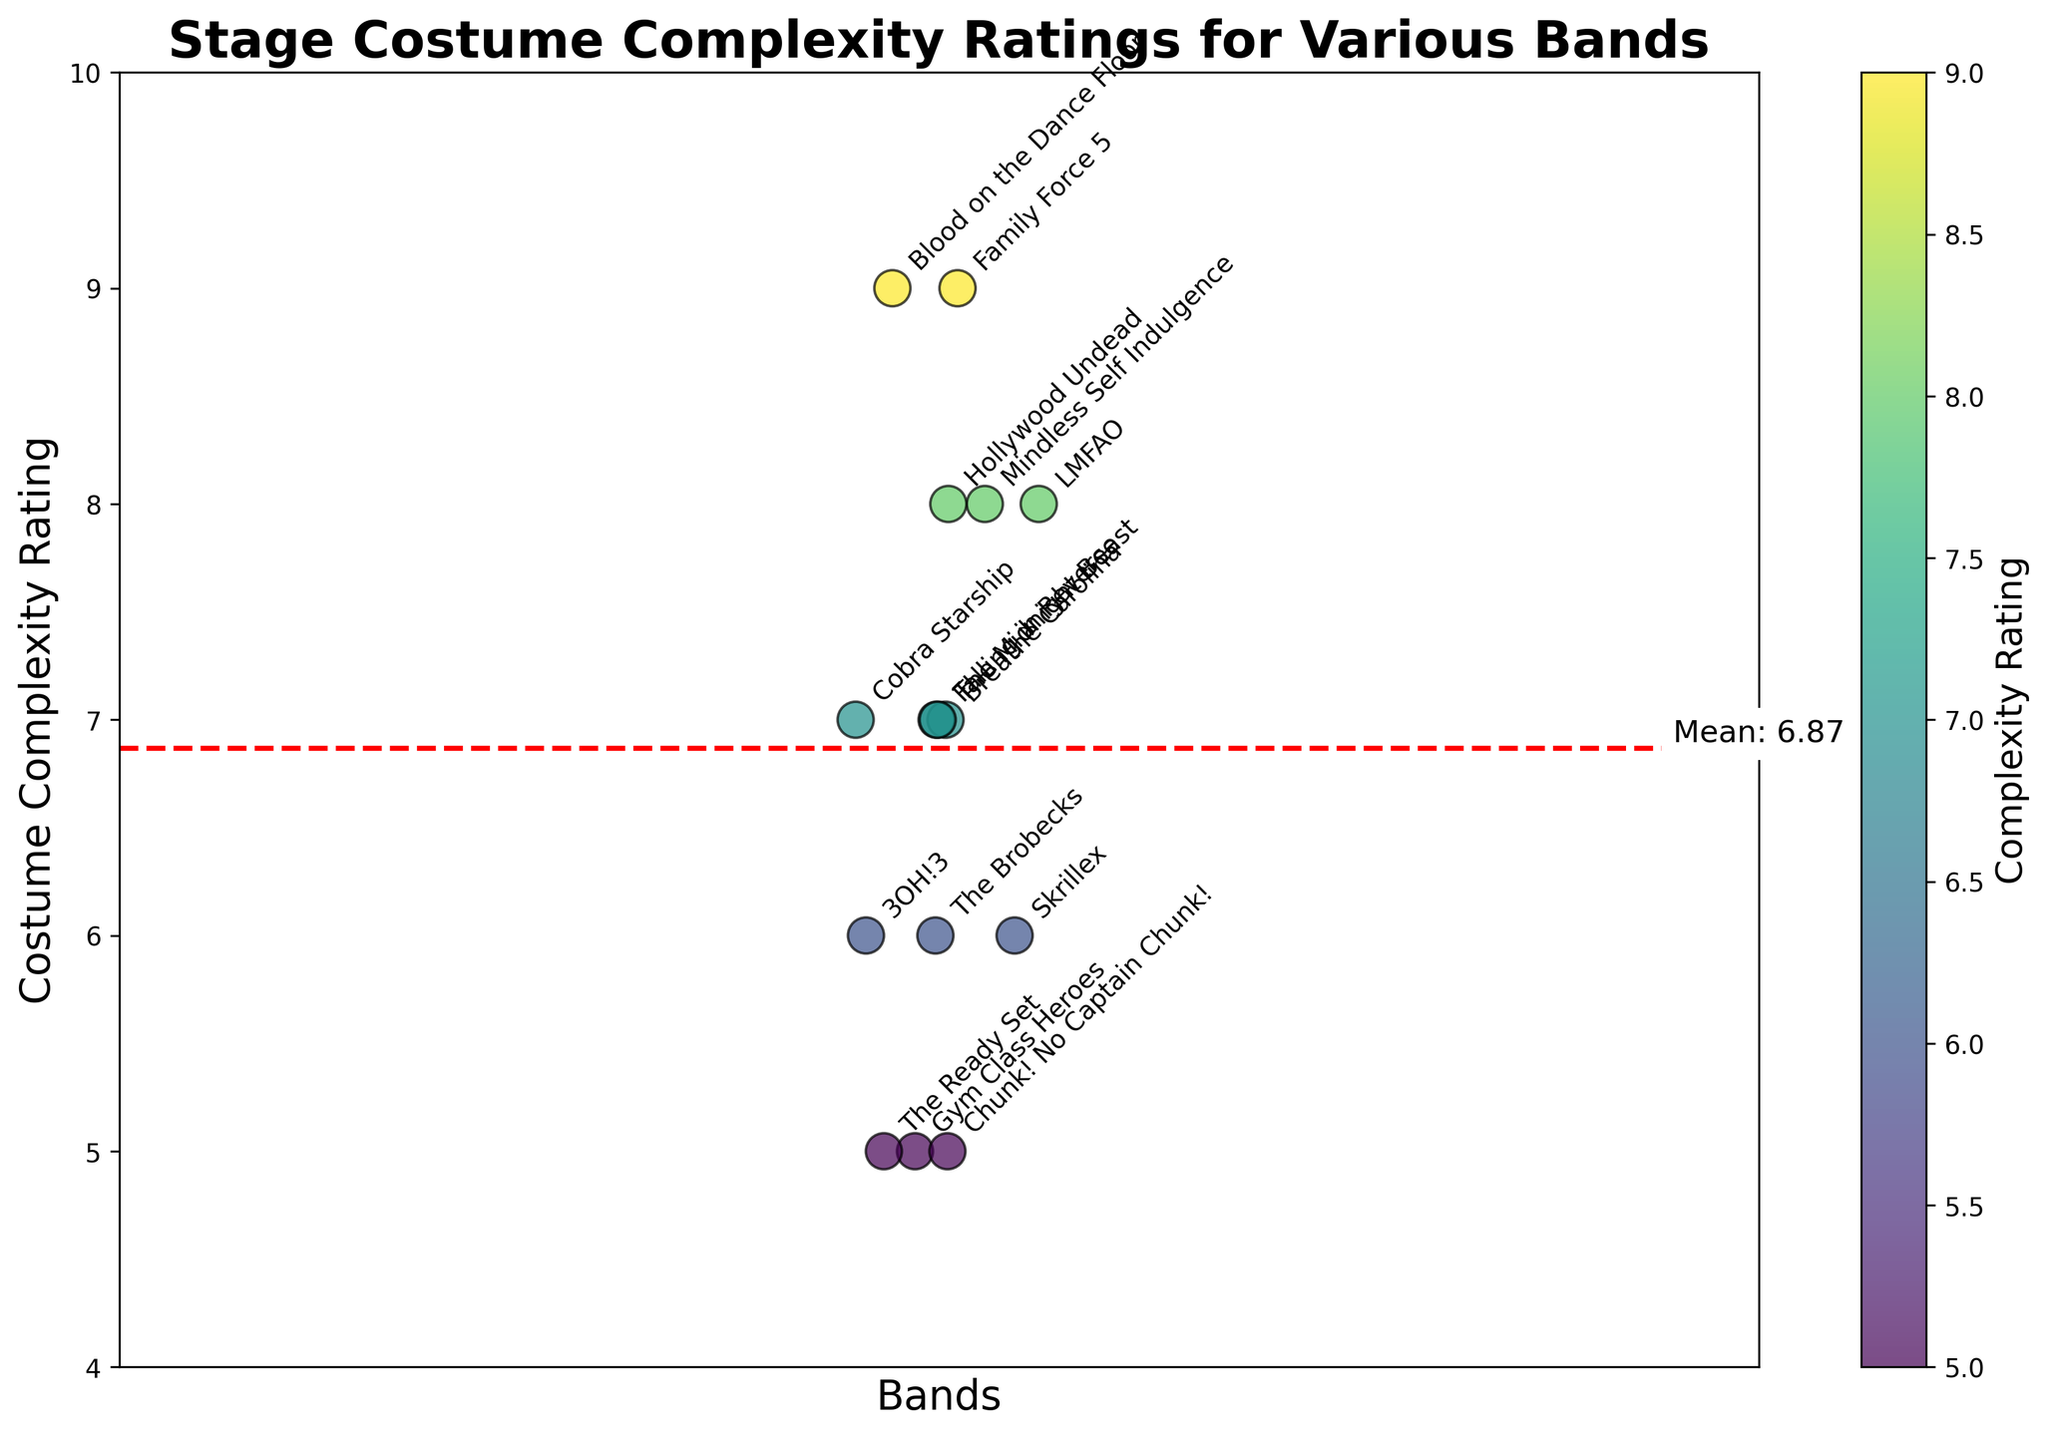What is the title of the plot? The title is usually located at the top of the plot. According to the provided code, it is set to 'Stage Costume Complexity Ratings for Various Bands'.
Answer: Stage Costume Complexity Ratings for Various Bands Which band has the highest costume complexity rating? Look for the data point with the highest y-value on the plot. Based on the data provided, both Family Force 5 and Blood on the Dance Floor have the highest costume complexity rating of 9.
Answer: Family Force 5 and Blood on the Dance Floor What is the mean costume complexity rating? A red dashed line represents the mean value in the plot, labeled with 'Mean: X.XX'. This value is also calculated in the code as the average of all complexity ratings.
Answer: 7.07 Which band has a costume complexity rating of 5? Find the data points at the y-value of 5 and check the annotations for the corresponding bands. According to the data, Gym Class Heroes, The Ready Set, and Chunk! No Captain Chunk! all have this rating.
Answer: Gym Class Heroes, The Ready Set, and Chunk! No Captain Chunk! How many bands have a costume complexity rating higher than the mean? First, identify the mean value from the horizontal red dashed line. Then, count how many data points have a y-value greater than this mean.
Answer: Six bands Which bands have exactly the same costume complexity rating of 8? Identify the data points at the y-value of 8 and check the annotations for the corresponding bands. According to the data, LMFAO, Mindless Self Indulgence, and Hollywood Undead have this rating.
Answer: LMFAO, Mindless Self Indulgence, and Hollywood Undead What is the range of costume complexity ratings in the plot? The range is calculated by subtracting the minimum value from the maximum value. According to the provided data, the minimum rating is 5 and the maximum is 9. Therefore, the range is 9 - 5.
Answer: 4 Are there any bands with the same costume complexity rating as Family Force 5? Family Force 5 has a rating of 9. Check if any other band has the same rating. According to the data, Blood on the Dance Floor also has a rating of 9.
Answer: Blood on the Dance Floor How many unique costume complexity ratings are represented in the plot? Identify the distinct y-values from the data points. According to the provided data, the unique ratings are 5, 6, 7, 8, and 9.
Answer: Five unique ratings 